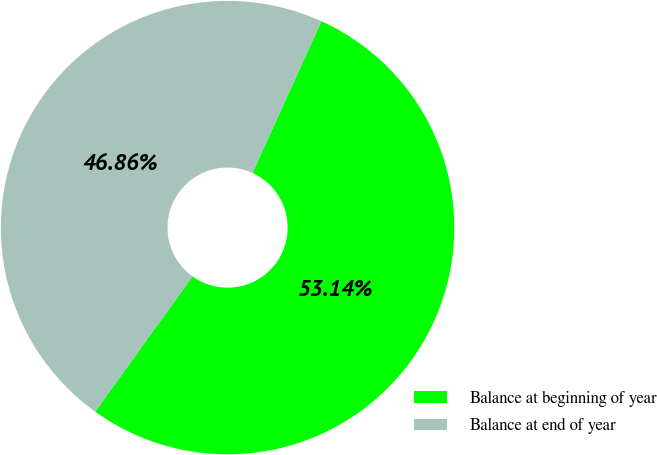Convert chart. <chart><loc_0><loc_0><loc_500><loc_500><pie_chart><fcel>Balance at beginning of year<fcel>Balance at end of year<nl><fcel>53.14%<fcel>46.86%<nl></chart> 